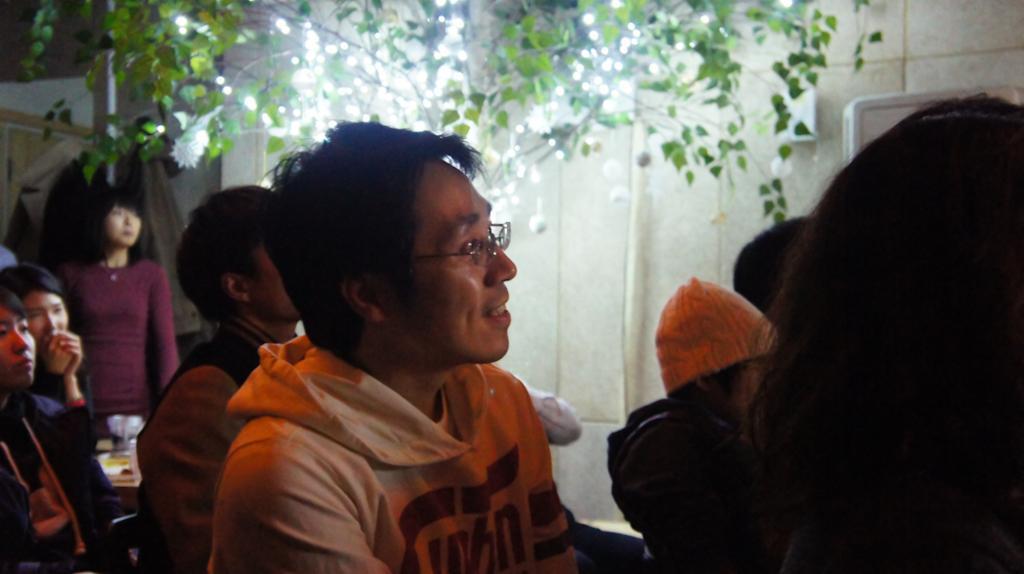How would you summarize this image in a sentence or two? In this image, there are a few people. We can see some objects. We can see the wall. We can also see a tree and some lights. We can also see a pole. 